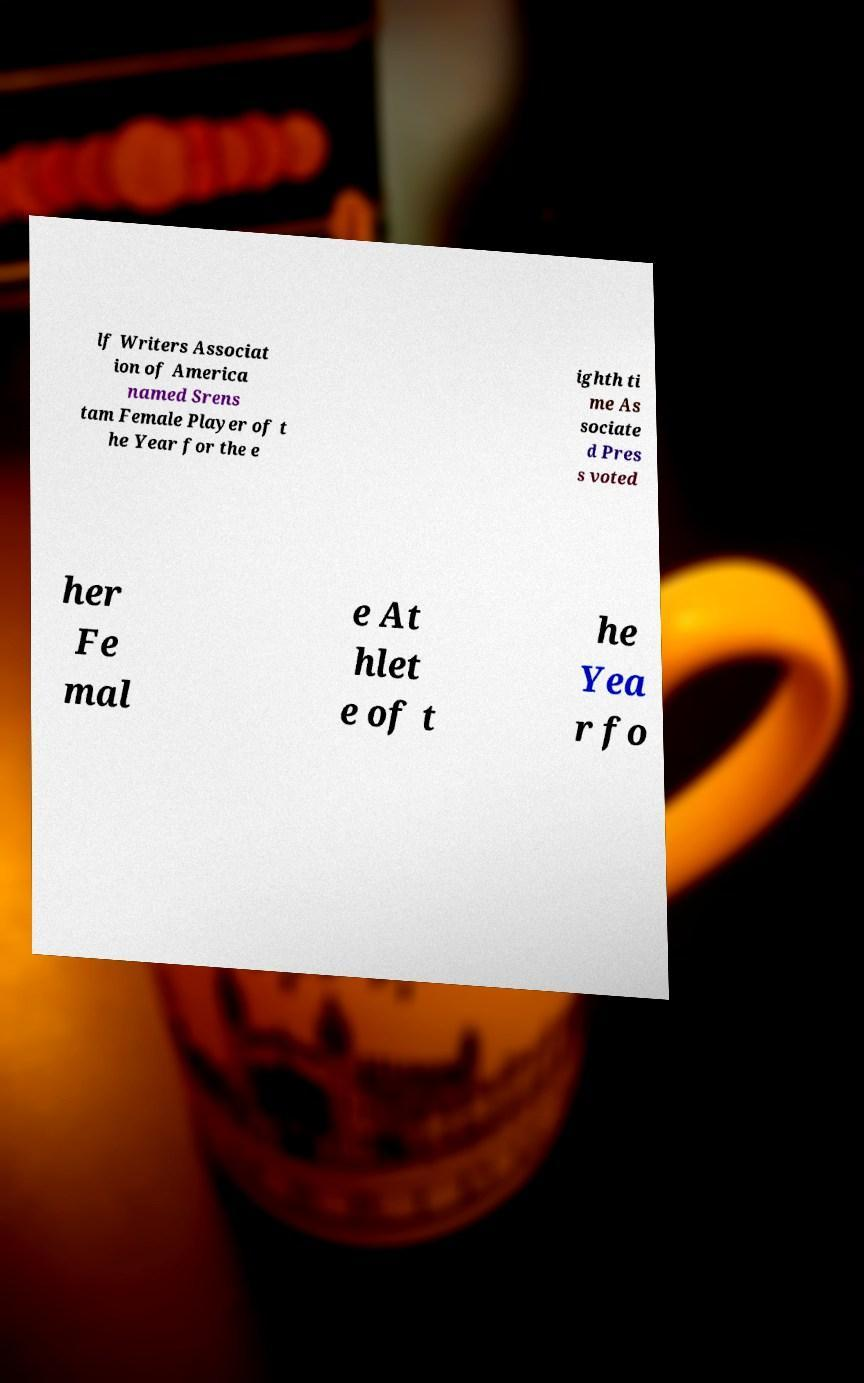Could you extract and type out the text from this image? lf Writers Associat ion of America named Srens tam Female Player of t he Year for the e ighth ti me As sociate d Pres s voted her Fe mal e At hlet e of t he Yea r fo 